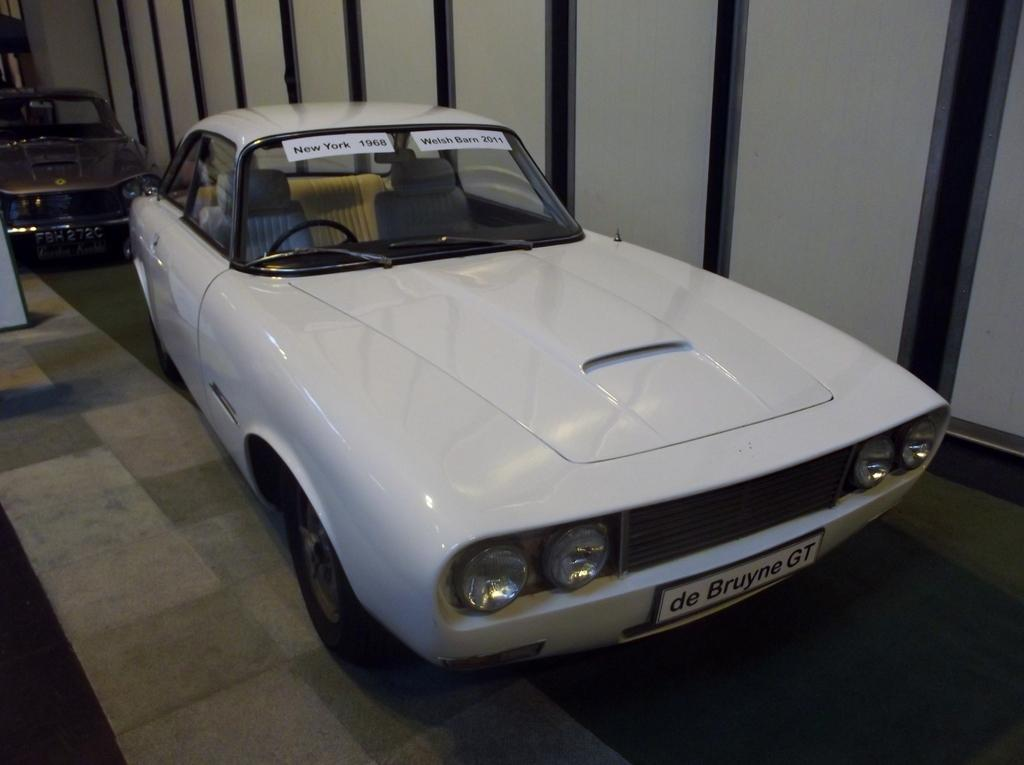What is the main subject of the image? There is a car in the image. Are there any additional details about the car? Yes, there are two papers pasted on the car. Can you describe the surrounding environment in the image? There is another car visible behind the first car. How does the crow interact with the growth in the room in the image? There is no crow or growth present in the image; it only features a car with papers pasted on it and another car behind it. 